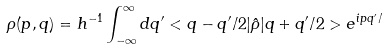Convert formula to latex. <formula><loc_0><loc_0><loc_500><loc_500>\rho ( p , q ) = h ^ { - 1 } \int _ { - \infty } ^ { \infty } d q ^ { \prime } < q - q ^ { \prime } / 2 | \hat { \rho } | q + q ^ { \prime } / 2 > e ^ { i p q ^ { \prime } / }</formula> 